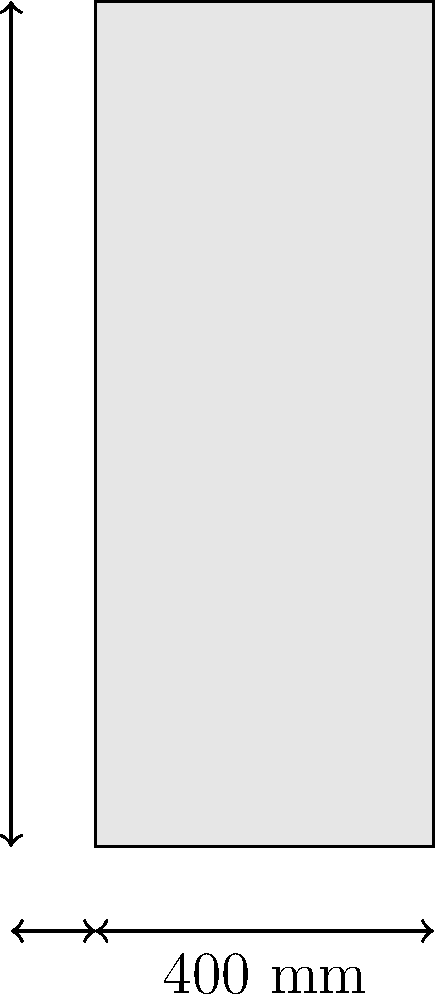You're reviewing plans for a new office building during your morning coffee break. A reinforced concrete column with dimensions 400 mm x 400 mm and a height of 1000 mm needs to support an axial load of 2000 kN. Given that the concrete strength $f'_c = 30$ MPa and the yield strength of steel $f_y = 420$ MPa, calculate the minimum area of longitudinal reinforcement required for this column according to ACI 318-19. Let's approach this step-by-step:

1) First, we need to calculate the gross area of the column:
   $A_g = 400 \text{ mm} \times 400 \text{ mm} = 160,000 \text{ mm}^2$

2) According to ACI 318-19, the minimum reinforcement ratio for tied columns is 1% of the gross area:
   $A_{s,min} = 0.01 A_g = 0.01 \times 160,000 = 1,600 \text{ mm}^2$

3) Now, let's check if this minimum reinforcement is sufficient. The nominal axial load capacity of the column can be calculated using:
   $P_n = 0.80[0.85f'_c(A_g - A_s) + f_yA_s]$

4) Substituting the values:
   $2000 \times 10^3 = 0.80[0.85 \times 30(160,000 - A_s) + 420A_s]$

5) Solving for $A_s$:
   $2500 \times 10^3 = 3264000 - 20.4A_s + 336A_s$
   $2500 \times 10^3 = 3264000 + 315.6A_s$
   $315.6A_s = 2500000 - 3264000 = -764000$
   $A_s = -764000 / 315.6 = -2421.7 \text{ mm}^2$

6) Since we got a negative value, it means that even the minimum reinforcement is more than sufficient.

Therefore, we should use the minimum required reinforcement of 1,600 mm².
Answer: 1,600 mm² 